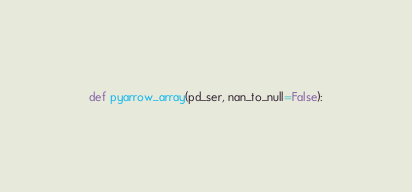Convert code to text. <code><loc_0><loc_0><loc_500><loc_500><_Python_>
def pyarrow_array(pd_ser, nan_to_null=False):</code> 